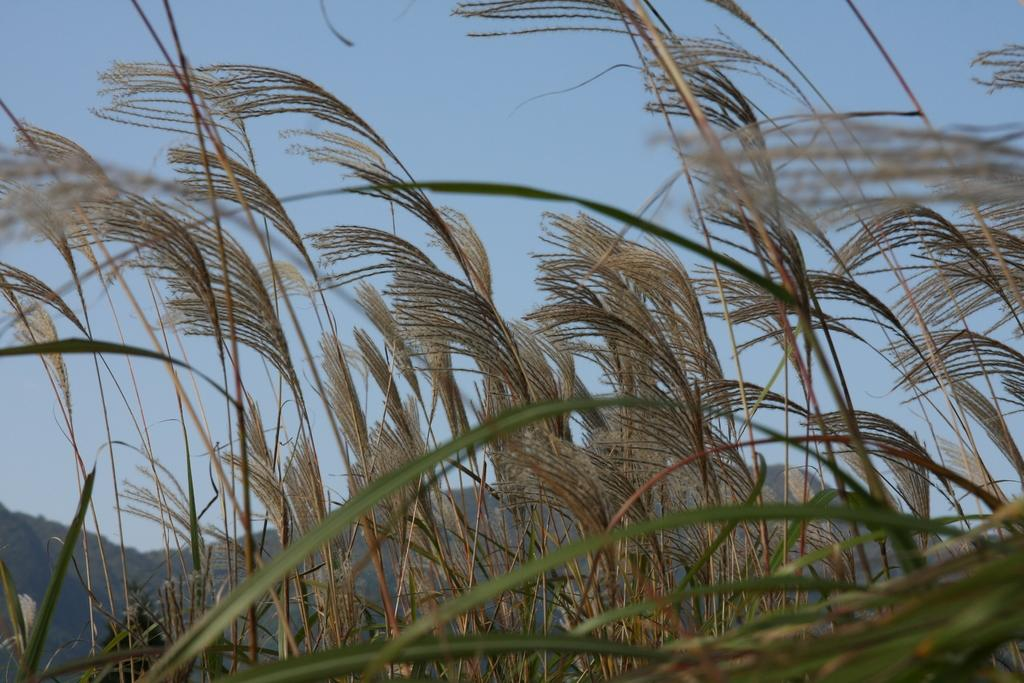What type of living organisms can be seen in the image? Plants can be seen in the image. What can be seen in the background of the image? Hills and the sky are visible in the background of the image. What sense do the plants use to communicate with each other in the image? Plants do not communicate with each other using senses like humans do, so this question cannot be answered based on the image. 